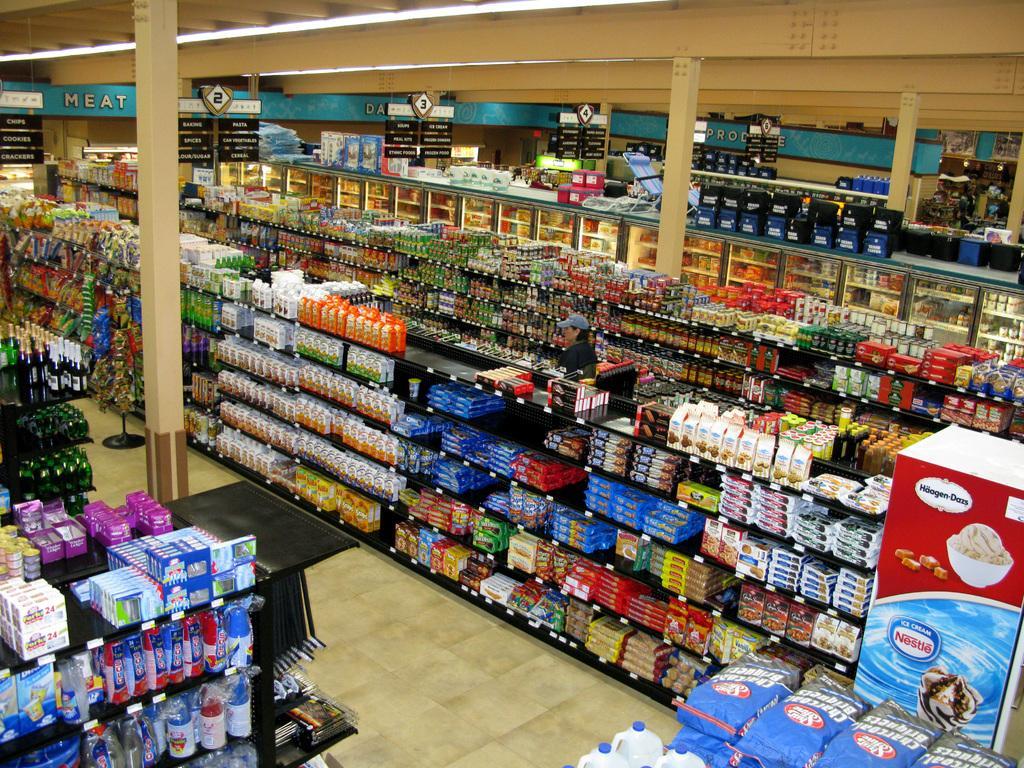Can you describe this image briefly? This is a picture of a super market. Here we can see all the groceries in particular racks and we can see one person wearing a blue cap. Here this is a ceiling roof. These are the number boards. 